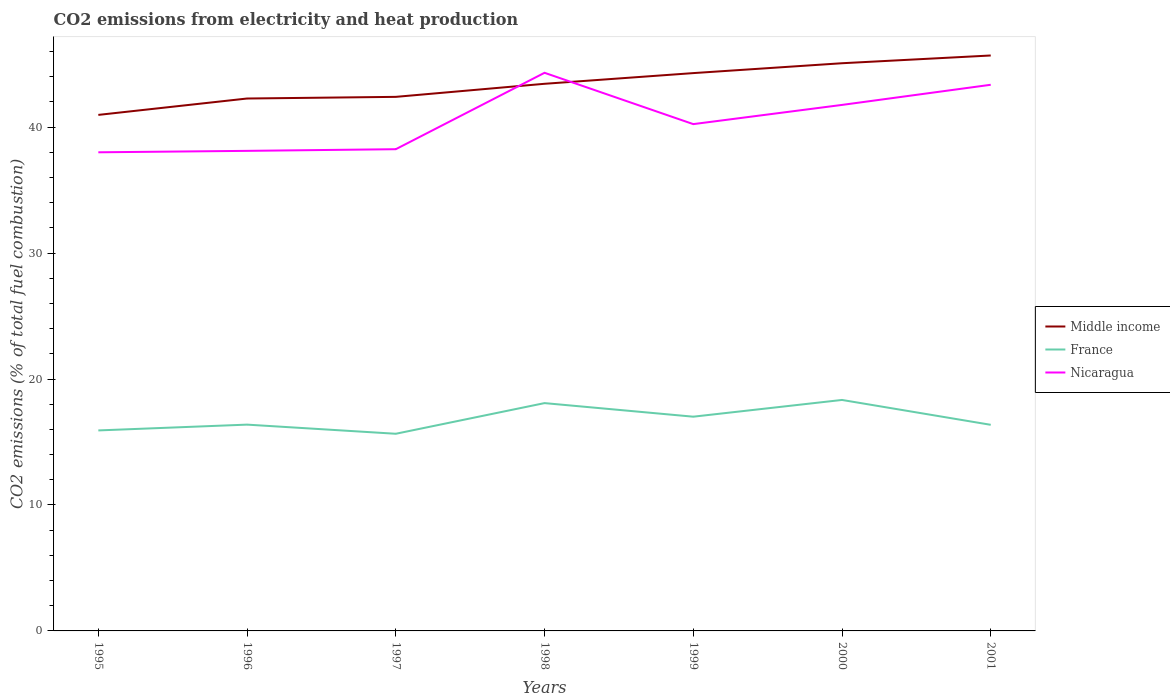How many different coloured lines are there?
Your answer should be very brief. 3. Is the number of lines equal to the number of legend labels?
Provide a short and direct response. Yes. Across all years, what is the maximum amount of CO2 emitted in Middle income?
Your response must be concise. 40.97. What is the total amount of CO2 emitted in France in the graph?
Provide a short and direct response. -1.96. What is the difference between the highest and the second highest amount of CO2 emitted in France?
Your answer should be compact. 2.68. How many lines are there?
Your answer should be very brief. 3. How many years are there in the graph?
Offer a very short reply. 7. Does the graph contain any zero values?
Provide a short and direct response. No. Does the graph contain grids?
Provide a succinct answer. No. Where does the legend appear in the graph?
Provide a succinct answer. Center right. How are the legend labels stacked?
Offer a very short reply. Vertical. What is the title of the graph?
Ensure brevity in your answer.  CO2 emissions from electricity and heat production. Does "Armenia" appear as one of the legend labels in the graph?
Give a very brief answer. No. What is the label or title of the Y-axis?
Provide a short and direct response. CO2 emissions (% of total fuel combustion). What is the CO2 emissions (% of total fuel combustion) of Middle income in 1995?
Ensure brevity in your answer.  40.97. What is the CO2 emissions (% of total fuel combustion) in France in 1995?
Give a very brief answer. 15.92. What is the CO2 emissions (% of total fuel combustion) in Nicaragua in 1995?
Provide a succinct answer. 38. What is the CO2 emissions (% of total fuel combustion) in Middle income in 1996?
Provide a short and direct response. 42.27. What is the CO2 emissions (% of total fuel combustion) of France in 1996?
Offer a terse response. 16.38. What is the CO2 emissions (% of total fuel combustion) of Nicaragua in 1996?
Keep it short and to the point. 38.11. What is the CO2 emissions (% of total fuel combustion) in Middle income in 1997?
Offer a very short reply. 42.4. What is the CO2 emissions (% of total fuel combustion) of France in 1997?
Provide a succinct answer. 15.65. What is the CO2 emissions (% of total fuel combustion) in Nicaragua in 1997?
Keep it short and to the point. 38.25. What is the CO2 emissions (% of total fuel combustion) of Middle income in 1998?
Provide a short and direct response. 43.44. What is the CO2 emissions (% of total fuel combustion) in France in 1998?
Make the answer very short. 18.09. What is the CO2 emissions (% of total fuel combustion) in Nicaragua in 1998?
Offer a terse response. 44.31. What is the CO2 emissions (% of total fuel combustion) of Middle income in 1999?
Your response must be concise. 44.29. What is the CO2 emissions (% of total fuel combustion) of France in 1999?
Provide a short and direct response. 17.01. What is the CO2 emissions (% of total fuel combustion) in Nicaragua in 1999?
Offer a terse response. 40.24. What is the CO2 emissions (% of total fuel combustion) of Middle income in 2000?
Your response must be concise. 45.07. What is the CO2 emissions (% of total fuel combustion) in France in 2000?
Keep it short and to the point. 18.34. What is the CO2 emissions (% of total fuel combustion) of Nicaragua in 2000?
Give a very brief answer. 41.76. What is the CO2 emissions (% of total fuel combustion) in Middle income in 2001?
Offer a very short reply. 45.69. What is the CO2 emissions (% of total fuel combustion) of France in 2001?
Provide a short and direct response. 16.36. What is the CO2 emissions (% of total fuel combustion) of Nicaragua in 2001?
Offer a terse response. 43.36. Across all years, what is the maximum CO2 emissions (% of total fuel combustion) of Middle income?
Your answer should be compact. 45.69. Across all years, what is the maximum CO2 emissions (% of total fuel combustion) of France?
Offer a terse response. 18.34. Across all years, what is the maximum CO2 emissions (% of total fuel combustion) of Nicaragua?
Your answer should be very brief. 44.31. Across all years, what is the minimum CO2 emissions (% of total fuel combustion) of Middle income?
Provide a short and direct response. 40.97. Across all years, what is the minimum CO2 emissions (% of total fuel combustion) in France?
Provide a succinct answer. 15.65. Across all years, what is the minimum CO2 emissions (% of total fuel combustion) of Nicaragua?
Give a very brief answer. 38. What is the total CO2 emissions (% of total fuel combustion) of Middle income in the graph?
Offer a terse response. 304.12. What is the total CO2 emissions (% of total fuel combustion) in France in the graph?
Your answer should be very brief. 117.75. What is the total CO2 emissions (% of total fuel combustion) in Nicaragua in the graph?
Your answer should be compact. 284.03. What is the difference between the CO2 emissions (% of total fuel combustion) in Middle income in 1995 and that in 1996?
Keep it short and to the point. -1.3. What is the difference between the CO2 emissions (% of total fuel combustion) of France in 1995 and that in 1996?
Your answer should be very brief. -0.46. What is the difference between the CO2 emissions (% of total fuel combustion) in Nicaragua in 1995 and that in 1996?
Provide a short and direct response. -0.11. What is the difference between the CO2 emissions (% of total fuel combustion) in Middle income in 1995 and that in 1997?
Ensure brevity in your answer.  -1.43. What is the difference between the CO2 emissions (% of total fuel combustion) in France in 1995 and that in 1997?
Give a very brief answer. 0.27. What is the difference between the CO2 emissions (% of total fuel combustion) in Nicaragua in 1995 and that in 1997?
Ensure brevity in your answer.  -0.25. What is the difference between the CO2 emissions (% of total fuel combustion) in Middle income in 1995 and that in 1998?
Your answer should be compact. -2.47. What is the difference between the CO2 emissions (% of total fuel combustion) of France in 1995 and that in 1998?
Keep it short and to the point. -2.17. What is the difference between the CO2 emissions (% of total fuel combustion) in Nicaragua in 1995 and that in 1998?
Provide a succinct answer. -6.31. What is the difference between the CO2 emissions (% of total fuel combustion) of Middle income in 1995 and that in 1999?
Ensure brevity in your answer.  -3.32. What is the difference between the CO2 emissions (% of total fuel combustion) of France in 1995 and that in 1999?
Make the answer very short. -1.09. What is the difference between the CO2 emissions (% of total fuel combustion) in Nicaragua in 1995 and that in 1999?
Provide a short and direct response. -2.24. What is the difference between the CO2 emissions (% of total fuel combustion) in Middle income in 1995 and that in 2000?
Provide a short and direct response. -4.1. What is the difference between the CO2 emissions (% of total fuel combustion) in France in 1995 and that in 2000?
Your response must be concise. -2.42. What is the difference between the CO2 emissions (% of total fuel combustion) of Nicaragua in 1995 and that in 2000?
Offer a very short reply. -3.76. What is the difference between the CO2 emissions (% of total fuel combustion) of Middle income in 1995 and that in 2001?
Make the answer very short. -4.72. What is the difference between the CO2 emissions (% of total fuel combustion) of France in 1995 and that in 2001?
Offer a terse response. -0.44. What is the difference between the CO2 emissions (% of total fuel combustion) in Nicaragua in 1995 and that in 2001?
Provide a succinct answer. -5.36. What is the difference between the CO2 emissions (% of total fuel combustion) of Middle income in 1996 and that in 1997?
Your answer should be compact. -0.13. What is the difference between the CO2 emissions (% of total fuel combustion) in France in 1996 and that in 1997?
Give a very brief answer. 0.73. What is the difference between the CO2 emissions (% of total fuel combustion) of Nicaragua in 1996 and that in 1997?
Ensure brevity in your answer.  -0.13. What is the difference between the CO2 emissions (% of total fuel combustion) in Middle income in 1996 and that in 1998?
Provide a succinct answer. -1.17. What is the difference between the CO2 emissions (% of total fuel combustion) of France in 1996 and that in 1998?
Your answer should be compact. -1.71. What is the difference between the CO2 emissions (% of total fuel combustion) in Nicaragua in 1996 and that in 1998?
Keep it short and to the point. -6.2. What is the difference between the CO2 emissions (% of total fuel combustion) in Middle income in 1996 and that in 1999?
Provide a short and direct response. -2.02. What is the difference between the CO2 emissions (% of total fuel combustion) of France in 1996 and that in 1999?
Offer a very short reply. -0.63. What is the difference between the CO2 emissions (% of total fuel combustion) in Nicaragua in 1996 and that in 1999?
Your answer should be compact. -2.12. What is the difference between the CO2 emissions (% of total fuel combustion) in Middle income in 1996 and that in 2000?
Offer a very short reply. -2.8. What is the difference between the CO2 emissions (% of total fuel combustion) in France in 1996 and that in 2000?
Offer a very short reply. -1.96. What is the difference between the CO2 emissions (% of total fuel combustion) in Nicaragua in 1996 and that in 2000?
Your answer should be compact. -3.65. What is the difference between the CO2 emissions (% of total fuel combustion) of Middle income in 1996 and that in 2001?
Ensure brevity in your answer.  -3.42. What is the difference between the CO2 emissions (% of total fuel combustion) in France in 1996 and that in 2001?
Provide a succinct answer. 0.01. What is the difference between the CO2 emissions (% of total fuel combustion) of Nicaragua in 1996 and that in 2001?
Your answer should be compact. -5.25. What is the difference between the CO2 emissions (% of total fuel combustion) in Middle income in 1997 and that in 1998?
Provide a short and direct response. -1.04. What is the difference between the CO2 emissions (% of total fuel combustion) in France in 1997 and that in 1998?
Offer a terse response. -2.43. What is the difference between the CO2 emissions (% of total fuel combustion) of Nicaragua in 1997 and that in 1998?
Offer a terse response. -6.07. What is the difference between the CO2 emissions (% of total fuel combustion) in Middle income in 1997 and that in 1999?
Your response must be concise. -1.89. What is the difference between the CO2 emissions (% of total fuel combustion) in France in 1997 and that in 1999?
Give a very brief answer. -1.36. What is the difference between the CO2 emissions (% of total fuel combustion) in Nicaragua in 1997 and that in 1999?
Keep it short and to the point. -1.99. What is the difference between the CO2 emissions (% of total fuel combustion) of Middle income in 1997 and that in 2000?
Your response must be concise. -2.67. What is the difference between the CO2 emissions (% of total fuel combustion) of France in 1997 and that in 2000?
Provide a succinct answer. -2.68. What is the difference between the CO2 emissions (% of total fuel combustion) of Nicaragua in 1997 and that in 2000?
Ensure brevity in your answer.  -3.52. What is the difference between the CO2 emissions (% of total fuel combustion) of Middle income in 1997 and that in 2001?
Keep it short and to the point. -3.28. What is the difference between the CO2 emissions (% of total fuel combustion) of France in 1997 and that in 2001?
Your answer should be compact. -0.71. What is the difference between the CO2 emissions (% of total fuel combustion) of Nicaragua in 1997 and that in 2001?
Your response must be concise. -5.11. What is the difference between the CO2 emissions (% of total fuel combustion) of Middle income in 1998 and that in 1999?
Provide a succinct answer. -0.85. What is the difference between the CO2 emissions (% of total fuel combustion) of France in 1998 and that in 1999?
Keep it short and to the point. 1.08. What is the difference between the CO2 emissions (% of total fuel combustion) of Nicaragua in 1998 and that in 1999?
Your answer should be very brief. 4.07. What is the difference between the CO2 emissions (% of total fuel combustion) in Middle income in 1998 and that in 2000?
Ensure brevity in your answer.  -1.63. What is the difference between the CO2 emissions (% of total fuel combustion) in France in 1998 and that in 2000?
Make the answer very short. -0.25. What is the difference between the CO2 emissions (% of total fuel combustion) in Nicaragua in 1998 and that in 2000?
Your answer should be very brief. 2.55. What is the difference between the CO2 emissions (% of total fuel combustion) of Middle income in 1998 and that in 2001?
Provide a succinct answer. -2.25. What is the difference between the CO2 emissions (% of total fuel combustion) of France in 1998 and that in 2001?
Make the answer very short. 1.72. What is the difference between the CO2 emissions (% of total fuel combustion) of Nicaragua in 1998 and that in 2001?
Your answer should be compact. 0.95. What is the difference between the CO2 emissions (% of total fuel combustion) in Middle income in 1999 and that in 2000?
Your response must be concise. -0.78. What is the difference between the CO2 emissions (% of total fuel combustion) in France in 1999 and that in 2000?
Offer a very short reply. -1.33. What is the difference between the CO2 emissions (% of total fuel combustion) in Nicaragua in 1999 and that in 2000?
Provide a succinct answer. -1.52. What is the difference between the CO2 emissions (% of total fuel combustion) of Middle income in 1999 and that in 2001?
Your response must be concise. -1.4. What is the difference between the CO2 emissions (% of total fuel combustion) of France in 1999 and that in 2001?
Your answer should be very brief. 0.65. What is the difference between the CO2 emissions (% of total fuel combustion) of Nicaragua in 1999 and that in 2001?
Provide a short and direct response. -3.12. What is the difference between the CO2 emissions (% of total fuel combustion) of Middle income in 2000 and that in 2001?
Your response must be concise. -0.61. What is the difference between the CO2 emissions (% of total fuel combustion) in France in 2000 and that in 2001?
Make the answer very short. 1.97. What is the difference between the CO2 emissions (% of total fuel combustion) in Nicaragua in 2000 and that in 2001?
Make the answer very short. -1.6. What is the difference between the CO2 emissions (% of total fuel combustion) of Middle income in 1995 and the CO2 emissions (% of total fuel combustion) of France in 1996?
Provide a short and direct response. 24.59. What is the difference between the CO2 emissions (% of total fuel combustion) of Middle income in 1995 and the CO2 emissions (% of total fuel combustion) of Nicaragua in 1996?
Keep it short and to the point. 2.86. What is the difference between the CO2 emissions (% of total fuel combustion) in France in 1995 and the CO2 emissions (% of total fuel combustion) in Nicaragua in 1996?
Offer a terse response. -22.19. What is the difference between the CO2 emissions (% of total fuel combustion) in Middle income in 1995 and the CO2 emissions (% of total fuel combustion) in France in 1997?
Your answer should be very brief. 25.32. What is the difference between the CO2 emissions (% of total fuel combustion) in Middle income in 1995 and the CO2 emissions (% of total fuel combustion) in Nicaragua in 1997?
Give a very brief answer. 2.72. What is the difference between the CO2 emissions (% of total fuel combustion) in France in 1995 and the CO2 emissions (% of total fuel combustion) in Nicaragua in 1997?
Ensure brevity in your answer.  -22.33. What is the difference between the CO2 emissions (% of total fuel combustion) in Middle income in 1995 and the CO2 emissions (% of total fuel combustion) in France in 1998?
Keep it short and to the point. 22.88. What is the difference between the CO2 emissions (% of total fuel combustion) in Middle income in 1995 and the CO2 emissions (% of total fuel combustion) in Nicaragua in 1998?
Your answer should be very brief. -3.34. What is the difference between the CO2 emissions (% of total fuel combustion) in France in 1995 and the CO2 emissions (% of total fuel combustion) in Nicaragua in 1998?
Offer a very short reply. -28.39. What is the difference between the CO2 emissions (% of total fuel combustion) of Middle income in 1995 and the CO2 emissions (% of total fuel combustion) of France in 1999?
Keep it short and to the point. 23.96. What is the difference between the CO2 emissions (% of total fuel combustion) in Middle income in 1995 and the CO2 emissions (% of total fuel combustion) in Nicaragua in 1999?
Make the answer very short. 0.73. What is the difference between the CO2 emissions (% of total fuel combustion) in France in 1995 and the CO2 emissions (% of total fuel combustion) in Nicaragua in 1999?
Provide a short and direct response. -24.32. What is the difference between the CO2 emissions (% of total fuel combustion) of Middle income in 1995 and the CO2 emissions (% of total fuel combustion) of France in 2000?
Provide a short and direct response. 22.63. What is the difference between the CO2 emissions (% of total fuel combustion) in Middle income in 1995 and the CO2 emissions (% of total fuel combustion) in Nicaragua in 2000?
Provide a short and direct response. -0.79. What is the difference between the CO2 emissions (% of total fuel combustion) in France in 1995 and the CO2 emissions (% of total fuel combustion) in Nicaragua in 2000?
Make the answer very short. -25.84. What is the difference between the CO2 emissions (% of total fuel combustion) of Middle income in 1995 and the CO2 emissions (% of total fuel combustion) of France in 2001?
Your response must be concise. 24.6. What is the difference between the CO2 emissions (% of total fuel combustion) of Middle income in 1995 and the CO2 emissions (% of total fuel combustion) of Nicaragua in 2001?
Offer a very short reply. -2.39. What is the difference between the CO2 emissions (% of total fuel combustion) of France in 1995 and the CO2 emissions (% of total fuel combustion) of Nicaragua in 2001?
Offer a very short reply. -27.44. What is the difference between the CO2 emissions (% of total fuel combustion) in Middle income in 1996 and the CO2 emissions (% of total fuel combustion) in France in 1997?
Offer a terse response. 26.62. What is the difference between the CO2 emissions (% of total fuel combustion) of Middle income in 1996 and the CO2 emissions (% of total fuel combustion) of Nicaragua in 1997?
Offer a very short reply. 4.02. What is the difference between the CO2 emissions (% of total fuel combustion) in France in 1996 and the CO2 emissions (% of total fuel combustion) in Nicaragua in 1997?
Give a very brief answer. -21.87. What is the difference between the CO2 emissions (% of total fuel combustion) in Middle income in 1996 and the CO2 emissions (% of total fuel combustion) in France in 1998?
Provide a succinct answer. 24.18. What is the difference between the CO2 emissions (% of total fuel combustion) in Middle income in 1996 and the CO2 emissions (% of total fuel combustion) in Nicaragua in 1998?
Your response must be concise. -2.04. What is the difference between the CO2 emissions (% of total fuel combustion) of France in 1996 and the CO2 emissions (% of total fuel combustion) of Nicaragua in 1998?
Offer a very short reply. -27.93. What is the difference between the CO2 emissions (% of total fuel combustion) in Middle income in 1996 and the CO2 emissions (% of total fuel combustion) in France in 1999?
Your response must be concise. 25.26. What is the difference between the CO2 emissions (% of total fuel combustion) of Middle income in 1996 and the CO2 emissions (% of total fuel combustion) of Nicaragua in 1999?
Give a very brief answer. 2.03. What is the difference between the CO2 emissions (% of total fuel combustion) of France in 1996 and the CO2 emissions (% of total fuel combustion) of Nicaragua in 1999?
Offer a very short reply. -23.86. What is the difference between the CO2 emissions (% of total fuel combustion) of Middle income in 1996 and the CO2 emissions (% of total fuel combustion) of France in 2000?
Provide a succinct answer. 23.93. What is the difference between the CO2 emissions (% of total fuel combustion) of Middle income in 1996 and the CO2 emissions (% of total fuel combustion) of Nicaragua in 2000?
Offer a very short reply. 0.51. What is the difference between the CO2 emissions (% of total fuel combustion) of France in 1996 and the CO2 emissions (% of total fuel combustion) of Nicaragua in 2000?
Your answer should be compact. -25.38. What is the difference between the CO2 emissions (% of total fuel combustion) of Middle income in 1996 and the CO2 emissions (% of total fuel combustion) of France in 2001?
Your answer should be very brief. 25.91. What is the difference between the CO2 emissions (% of total fuel combustion) in Middle income in 1996 and the CO2 emissions (% of total fuel combustion) in Nicaragua in 2001?
Your response must be concise. -1.09. What is the difference between the CO2 emissions (% of total fuel combustion) of France in 1996 and the CO2 emissions (% of total fuel combustion) of Nicaragua in 2001?
Your answer should be very brief. -26.98. What is the difference between the CO2 emissions (% of total fuel combustion) in Middle income in 1997 and the CO2 emissions (% of total fuel combustion) in France in 1998?
Make the answer very short. 24.31. What is the difference between the CO2 emissions (% of total fuel combustion) of Middle income in 1997 and the CO2 emissions (% of total fuel combustion) of Nicaragua in 1998?
Your response must be concise. -1.91. What is the difference between the CO2 emissions (% of total fuel combustion) in France in 1997 and the CO2 emissions (% of total fuel combustion) in Nicaragua in 1998?
Your response must be concise. -28.66. What is the difference between the CO2 emissions (% of total fuel combustion) of Middle income in 1997 and the CO2 emissions (% of total fuel combustion) of France in 1999?
Your answer should be very brief. 25.39. What is the difference between the CO2 emissions (% of total fuel combustion) in Middle income in 1997 and the CO2 emissions (% of total fuel combustion) in Nicaragua in 1999?
Offer a terse response. 2.16. What is the difference between the CO2 emissions (% of total fuel combustion) of France in 1997 and the CO2 emissions (% of total fuel combustion) of Nicaragua in 1999?
Give a very brief answer. -24.58. What is the difference between the CO2 emissions (% of total fuel combustion) of Middle income in 1997 and the CO2 emissions (% of total fuel combustion) of France in 2000?
Your answer should be compact. 24.06. What is the difference between the CO2 emissions (% of total fuel combustion) in Middle income in 1997 and the CO2 emissions (% of total fuel combustion) in Nicaragua in 2000?
Ensure brevity in your answer.  0.64. What is the difference between the CO2 emissions (% of total fuel combustion) in France in 1997 and the CO2 emissions (% of total fuel combustion) in Nicaragua in 2000?
Give a very brief answer. -26.11. What is the difference between the CO2 emissions (% of total fuel combustion) of Middle income in 1997 and the CO2 emissions (% of total fuel combustion) of France in 2001?
Keep it short and to the point. 26.04. What is the difference between the CO2 emissions (% of total fuel combustion) of Middle income in 1997 and the CO2 emissions (% of total fuel combustion) of Nicaragua in 2001?
Keep it short and to the point. -0.96. What is the difference between the CO2 emissions (% of total fuel combustion) of France in 1997 and the CO2 emissions (% of total fuel combustion) of Nicaragua in 2001?
Offer a very short reply. -27.71. What is the difference between the CO2 emissions (% of total fuel combustion) of Middle income in 1998 and the CO2 emissions (% of total fuel combustion) of France in 1999?
Keep it short and to the point. 26.43. What is the difference between the CO2 emissions (% of total fuel combustion) in Middle income in 1998 and the CO2 emissions (% of total fuel combustion) in Nicaragua in 1999?
Your answer should be compact. 3.2. What is the difference between the CO2 emissions (% of total fuel combustion) of France in 1998 and the CO2 emissions (% of total fuel combustion) of Nicaragua in 1999?
Ensure brevity in your answer.  -22.15. What is the difference between the CO2 emissions (% of total fuel combustion) in Middle income in 1998 and the CO2 emissions (% of total fuel combustion) in France in 2000?
Ensure brevity in your answer.  25.1. What is the difference between the CO2 emissions (% of total fuel combustion) of Middle income in 1998 and the CO2 emissions (% of total fuel combustion) of Nicaragua in 2000?
Your answer should be very brief. 1.68. What is the difference between the CO2 emissions (% of total fuel combustion) in France in 1998 and the CO2 emissions (% of total fuel combustion) in Nicaragua in 2000?
Provide a succinct answer. -23.67. What is the difference between the CO2 emissions (% of total fuel combustion) of Middle income in 1998 and the CO2 emissions (% of total fuel combustion) of France in 2001?
Give a very brief answer. 27.07. What is the difference between the CO2 emissions (% of total fuel combustion) in Middle income in 1998 and the CO2 emissions (% of total fuel combustion) in Nicaragua in 2001?
Give a very brief answer. 0.08. What is the difference between the CO2 emissions (% of total fuel combustion) of France in 1998 and the CO2 emissions (% of total fuel combustion) of Nicaragua in 2001?
Make the answer very short. -25.27. What is the difference between the CO2 emissions (% of total fuel combustion) of Middle income in 1999 and the CO2 emissions (% of total fuel combustion) of France in 2000?
Your response must be concise. 25.95. What is the difference between the CO2 emissions (% of total fuel combustion) in Middle income in 1999 and the CO2 emissions (% of total fuel combustion) in Nicaragua in 2000?
Offer a terse response. 2.53. What is the difference between the CO2 emissions (% of total fuel combustion) in France in 1999 and the CO2 emissions (% of total fuel combustion) in Nicaragua in 2000?
Offer a very short reply. -24.75. What is the difference between the CO2 emissions (% of total fuel combustion) in Middle income in 1999 and the CO2 emissions (% of total fuel combustion) in France in 2001?
Keep it short and to the point. 27.92. What is the difference between the CO2 emissions (% of total fuel combustion) in Middle income in 1999 and the CO2 emissions (% of total fuel combustion) in Nicaragua in 2001?
Your response must be concise. 0.93. What is the difference between the CO2 emissions (% of total fuel combustion) in France in 1999 and the CO2 emissions (% of total fuel combustion) in Nicaragua in 2001?
Your answer should be compact. -26.35. What is the difference between the CO2 emissions (% of total fuel combustion) of Middle income in 2000 and the CO2 emissions (% of total fuel combustion) of France in 2001?
Provide a succinct answer. 28.71. What is the difference between the CO2 emissions (% of total fuel combustion) of Middle income in 2000 and the CO2 emissions (% of total fuel combustion) of Nicaragua in 2001?
Give a very brief answer. 1.71. What is the difference between the CO2 emissions (% of total fuel combustion) in France in 2000 and the CO2 emissions (% of total fuel combustion) in Nicaragua in 2001?
Provide a short and direct response. -25.02. What is the average CO2 emissions (% of total fuel combustion) in Middle income per year?
Offer a terse response. 43.45. What is the average CO2 emissions (% of total fuel combustion) in France per year?
Your answer should be compact. 16.82. What is the average CO2 emissions (% of total fuel combustion) in Nicaragua per year?
Your response must be concise. 40.58. In the year 1995, what is the difference between the CO2 emissions (% of total fuel combustion) of Middle income and CO2 emissions (% of total fuel combustion) of France?
Give a very brief answer. 25.05. In the year 1995, what is the difference between the CO2 emissions (% of total fuel combustion) in Middle income and CO2 emissions (% of total fuel combustion) in Nicaragua?
Your answer should be very brief. 2.97. In the year 1995, what is the difference between the CO2 emissions (% of total fuel combustion) in France and CO2 emissions (% of total fuel combustion) in Nicaragua?
Give a very brief answer. -22.08. In the year 1996, what is the difference between the CO2 emissions (% of total fuel combustion) in Middle income and CO2 emissions (% of total fuel combustion) in France?
Your response must be concise. 25.89. In the year 1996, what is the difference between the CO2 emissions (% of total fuel combustion) of Middle income and CO2 emissions (% of total fuel combustion) of Nicaragua?
Provide a short and direct response. 4.16. In the year 1996, what is the difference between the CO2 emissions (% of total fuel combustion) in France and CO2 emissions (% of total fuel combustion) in Nicaragua?
Offer a terse response. -21.74. In the year 1997, what is the difference between the CO2 emissions (% of total fuel combustion) of Middle income and CO2 emissions (% of total fuel combustion) of France?
Provide a short and direct response. 26.75. In the year 1997, what is the difference between the CO2 emissions (% of total fuel combustion) in Middle income and CO2 emissions (% of total fuel combustion) in Nicaragua?
Your response must be concise. 4.16. In the year 1997, what is the difference between the CO2 emissions (% of total fuel combustion) of France and CO2 emissions (% of total fuel combustion) of Nicaragua?
Your answer should be very brief. -22.59. In the year 1998, what is the difference between the CO2 emissions (% of total fuel combustion) in Middle income and CO2 emissions (% of total fuel combustion) in France?
Your answer should be very brief. 25.35. In the year 1998, what is the difference between the CO2 emissions (% of total fuel combustion) of Middle income and CO2 emissions (% of total fuel combustion) of Nicaragua?
Your response must be concise. -0.87. In the year 1998, what is the difference between the CO2 emissions (% of total fuel combustion) of France and CO2 emissions (% of total fuel combustion) of Nicaragua?
Ensure brevity in your answer.  -26.22. In the year 1999, what is the difference between the CO2 emissions (% of total fuel combustion) of Middle income and CO2 emissions (% of total fuel combustion) of France?
Keep it short and to the point. 27.28. In the year 1999, what is the difference between the CO2 emissions (% of total fuel combustion) in Middle income and CO2 emissions (% of total fuel combustion) in Nicaragua?
Offer a terse response. 4.05. In the year 1999, what is the difference between the CO2 emissions (% of total fuel combustion) of France and CO2 emissions (% of total fuel combustion) of Nicaragua?
Give a very brief answer. -23.23. In the year 2000, what is the difference between the CO2 emissions (% of total fuel combustion) of Middle income and CO2 emissions (% of total fuel combustion) of France?
Provide a succinct answer. 26.73. In the year 2000, what is the difference between the CO2 emissions (% of total fuel combustion) in Middle income and CO2 emissions (% of total fuel combustion) in Nicaragua?
Provide a succinct answer. 3.31. In the year 2000, what is the difference between the CO2 emissions (% of total fuel combustion) of France and CO2 emissions (% of total fuel combustion) of Nicaragua?
Offer a very short reply. -23.42. In the year 2001, what is the difference between the CO2 emissions (% of total fuel combustion) in Middle income and CO2 emissions (% of total fuel combustion) in France?
Offer a terse response. 29.32. In the year 2001, what is the difference between the CO2 emissions (% of total fuel combustion) of Middle income and CO2 emissions (% of total fuel combustion) of Nicaragua?
Offer a terse response. 2.32. In the year 2001, what is the difference between the CO2 emissions (% of total fuel combustion) in France and CO2 emissions (% of total fuel combustion) in Nicaragua?
Your answer should be compact. -27. What is the ratio of the CO2 emissions (% of total fuel combustion) in Middle income in 1995 to that in 1996?
Provide a short and direct response. 0.97. What is the ratio of the CO2 emissions (% of total fuel combustion) of France in 1995 to that in 1996?
Your answer should be compact. 0.97. What is the ratio of the CO2 emissions (% of total fuel combustion) of Middle income in 1995 to that in 1997?
Ensure brevity in your answer.  0.97. What is the ratio of the CO2 emissions (% of total fuel combustion) of Nicaragua in 1995 to that in 1997?
Provide a succinct answer. 0.99. What is the ratio of the CO2 emissions (% of total fuel combustion) of Middle income in 1995 to that in 1998?
Provide a short and direct response. 0.94. What is the ratio of the CO2 emissions (% of total fuel combustion) of France in 1995 to that in 1998?
Your response must be concise. 0.88. What is the ratio of the CO2 emissions (% of total fuel combustion) in Nicaragua in 1995 to that in 1998?
Ensure brevity in your answer.  0.86. What is the ratio of the CO2 emissions (% of total fuel combustion) of Middle income in 1995 to that in 1999?
Ensure brevity in your answer.  0.93. What is the ratio of the CO2 emissions (% of total fuel combustion) of France in 1995 to that in 1999?
Your answer should be compact. 0.94. What is the ratio of the CO2 emissions (% of total fuel combustion) of Middle income in 1995 to that in 2000?
Offer a very short reply. 0.91. What is the ratio of the CO2 emissions (% of total fuel combustion) in France in 1995 to that in 2000?
Give a very brief answer. 0.87. What is the ratio of the CO2 emissions (% of total fuel combustion) in Nicaragua in 1995 to that in 2000?
Make the answer very short. 0.91. What is the ratio of the CO2 emissions (% of total fuel combustion) in Middle income in 1995 to that in 2001?
Your response must be concise. 0.9. What is the ratio of the CO2 emissions (% of total fuel combustion) of France in 1995 to that in 2001?
Your answer should be very brief. 0.97. What is the ratio of the CO2 emissions (% of total fuel combustion) in Nicaragua in 1995 to that in 2001?
Your answer should be compact. 0.88. What is the ratio of the CO2 emissions (% of total fuel combustion) of Middle income in 1996 to that in 1997?
Provide a succinct answer. 1. What is the ratio of the CO2 emissions (% of total fuel combustion) in France in 1996 to that in 1997?
Ensure brevity in your answer.  1.05. What is the ratio of the CO2 emissions (% of total fuel combustion) of Middle income in 1996 to that in 1998?
Your answer should be very brief. 0.97. What is the ratio of the CO2 emissions (% of total fuel combustion) in France in 1996 to that in 1998?
Provide a short and direct response. 0.91. What is the ratio of the CO2 emissions (% of total fuel combustion) in Nicaragua in 1996 to that in 1998?
Keep it short and to the point. 0.86. What is the ratio of the CO2 emissions (% of total fuel combustion) of Middle income in 1996 to that in 1999?
Your response must be concise. 0.95. What is the ratio of the CO2 emissions (% of total fuel combustion) of France in 1996 to that in 1999?
Make the answer very short. 0.96. What is the ratio of the CO2 emissions (% of total fuel combustion) in Nicaragua in 1996 to that in 1999?
Offer a very short reply. 0.95. What is the ratio of the CO2 emissions (% of total fuel combustion) of Middle income in 1996 to that in 2000?
Offer a terse response. 0.94. What is the ratio of the CO2 emissions (% of total fuel combustion) of France in 1996 to that in 2000?
Offer a very short reply. 0.89. What is the ratio of the CO2 emissions (% of total fuel combustion) in Nicaragua in 1996 to that in 2000?
Keep it short and to the point. 0.91. What is the ratio of the CO2 emissions (% of total fuel combustion) of Middle income in 1996 to that in 2001?
Offer a terse response. 0.93. What is the ratio of the CO2 emissions (% of total fuel combustion) in France in 1996 to that in 2001?
Provide a short and direct response. 1. What is the ratio of the CO2 emissions (% of total fuel combustion) in Nicaragua in 1996 to that in 2001?
Offer a terse response. 0.88. What is the ratio of the CO2 emissions (% of total fuel combustion) of Middle income in 1997 to that in 1998?
Keep it short and to the point. 0.98. What is the ratio of the CO2 emissions (% of total fuel combustion) of France in 1997 to that in 1998?
Keep it short and to the point. 0.87. What is the ratio of the CO2 emissions (% of total fuel combustion) in Nicaragua in 1997 to that in 1998?
Make the answer very short. 0.86. What is the ratio of the CO2 emissions (% of total fuel combustion) in Middle income in 1997 to that in 1999?
Your response must be concise. 0.96. What is the ratio of the CO2 emissions (% of total fuel combustion) of France in 1997 to that in 1999?
Provide a succinct answer. 0.92. What is the ratio of the CO2 emissions (% of total fuel combustion) of Nicaragua in 1997 to that in 1999?
Make the answer very short. 0.95. What is the ratio of the CO2 emissions (% of total fuel combustion) in Middle income in 1997 to that in 2000?
Offer a very short reply. 0.94. What is the ratio of the CO2 emissions (% of total fuel combustion) in France in 1997 to that in 2000?
Make the answer very short. 0.85. What is the ratio of the CO2 emissions (% of total fuel combustion) of Nicaragua in 1997 to that in 2000?
Offer a very short reply. 0.92. What is the ratio of the CO2 emissions (% of total fuel combustion) of Middle income in 1997 to that in 2001?
Your answer should be compact. 0.93. What is the ratio of the CO2 emissions (% of total fuel combustion) of France in 1997 to that in 2001?
Your answer should be compact. 0.96. What is the ratio of the CO2 emissions (% of total fuel combustion) in Nicaragua in 1997 to that in 2001?
Provide a succinct answer. 0.88. What is the ratio of the CO2 emissions (% of total fuel combustion) of Middle income in 1998 to that in 1999?
Keep it short and to the point. 0.98. What is the ratio of the CO2 emissions (% of total fuel combustion) in France in 1998 to that in 1999?
Provide a short and direct response. 1.06. What is the ratio of the CO2 emissions (% of total fuel combustion) of Nicaragua in 1998 to that in 1999?
Give a very brief answer. 1.1. What is the ratio of the CO2 emissions (% of total fuel combustion) in Middle income in 1998 to that in 2000?
Make the answer very short. 0.96. What is the ratio of the CO2 emissions (% of total fuel combustion) in France in 1998 to that in 2000?
Your answer should be very brief. 0.99. What is the ratio of the CO2 emissions (% of total fuel combustion) in Nicaragua in 1998 to that in 2000?
Offer a very short reply. 1.06. What is the ratio of the CO2 emissions (% of total fuel combustion) in Middle income in 1998 to that in 2001?
Offer a terse response. 0.95. What is the ratio of the CO2 emissions (% of total fuel combustion) in France in 1998 to that in 2001?
Ensure brevity in your answer.  1.11. What is the ratio of the CO2 emissions (% of total fuel combustion) in Nicaragua in 1998 to that in 2001?
Your answer should be very brief. 1.02. What is the ratio of the CO2 emissions (% of total fuel combustion) of Middle income in 1999 to that in 2000?
Keep it short and to the point. 0.98. What is the ratio of the CO2 emissions (% of total fuel combustion) in France in 1999 to that in 2000?
Keep it short and to the point. 0.93. What is the ratio of the CO2 emissions (% of total fuel combustion) in Nicaragua in 1999 to that in 2000?
Your response must be concise. 0.96. What is the ratio of the CO2 emissions (% of total fuel combustion) of Middle income in 1999 to that in 2001?
Offer a terse response. 0.97. What is the ratio of the CO2 emissions (% of total fuel combustion) in France in 1999 to that in 2001?
Your answer should be very brief. 1.04. What is the ratio of the CO2 emissions (% of total fuel combustion) in Nicaragua in 1999 to that in 2001?
Your answer should be very brief. 0.93. What is the ratio of the CO2 emissions (% of total fuel combustion) in Middle income in 2000 to that in 2001?
Your answer should be very brief. 0.99. What is the ratio of the CO2 emissions (% of total fuel combustion) of France in 2000 to that in 2001?
Offer a very short reply. 1.12. What is the ratio of the CO2 emissions (% of total fuel combustion) in Nicaragua in 2000 to that in 2001?
Offer a terse response. 0.96. What is the difference between the highest and the second highest CO2 emissions (% of total fuel combustion) in Middle income?
Offer a very short reply. 0.61. What is the difference between the highest and the second highest CO2 emissions (% of total fuel combustion) in France?
Ensure brevity in your answer.  0.25. What is the difference between the highest and the second highest CO2 emissions (% of total fuel combustion) in Nicaragua?
Keep it short and to the point. 0.95. What is the difference between the highest and the lowest CO2 emissions (% of total fuel combustion) of Middle income?
Your answer should be compact. 4.72. What is the difference between the highest and the lowest CO2 emissions (% of total fuel combustion) of France?
Your response must be concise. 2.68. What is the difference between the highest and the lowest CO2 emissions (% of total fuel combustion) in Nicaragua?
Offer a terse response. 6.31. 